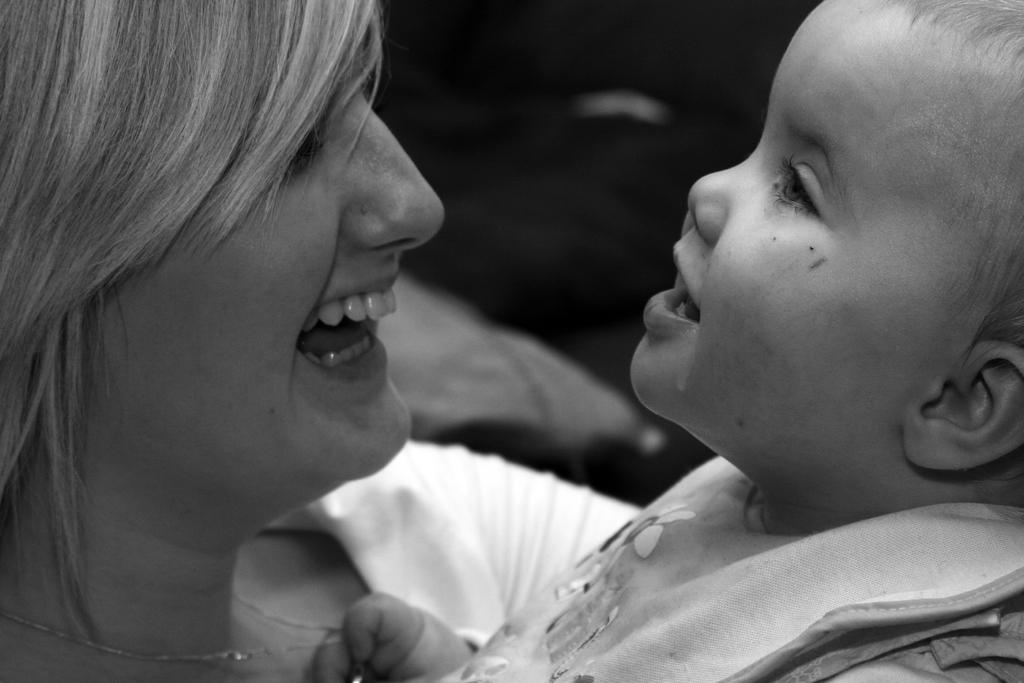How many people are in the image? There are two persons in the image. Can you describe the facial expression of one of the persons? One of the persons is smiling. What can be observed about the background of the image? The background of the image is blurred. What type of scarecrow can be seen in the image? There is no scarecrow present in the image. How does the passenger feel in the image? There is no passenger mentioned in the image, so it's not possible to determine how they might feel. 